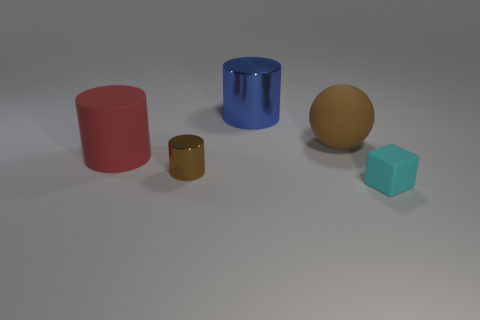There is a metallic cylinder that is the same color as the matte ball; what is its size?
Keep it short and to the point. Small. Is there a metallic thing that has the same size as the red cylinder?
Your answer should be compact. Yes. There is a blue thing; is its shape the same as the brown object that is on the right side of the small brown thing?
Keep it short and to the point. No. Is the size of the matte object that is on the left side of the large metal object the same as the brown object in front of the big red thing?
Keep it short and to the point. No. What number of other objects are the same shape as the blue object?
Make the answer very short. 2. The brown object that is in front of the big object that is on the right side of the big blue object is made of what material?
Make the answer very short. Metal. How many matte objects are large blue blocks or brown spheres?
Ensure brevity in your answer.  1. Is there a metallic cylinder to the left of the small thing that is behind the small cyan rubber cube?
Keep it short and to the point. No. How many things are big red matte objects that are left of the big brown matte ball or big rubber objects that are left of the brown matte thing?
Offer a very short reply. 1. Are there any other things of the same color as the small cube?
Make the answer very short. No. 